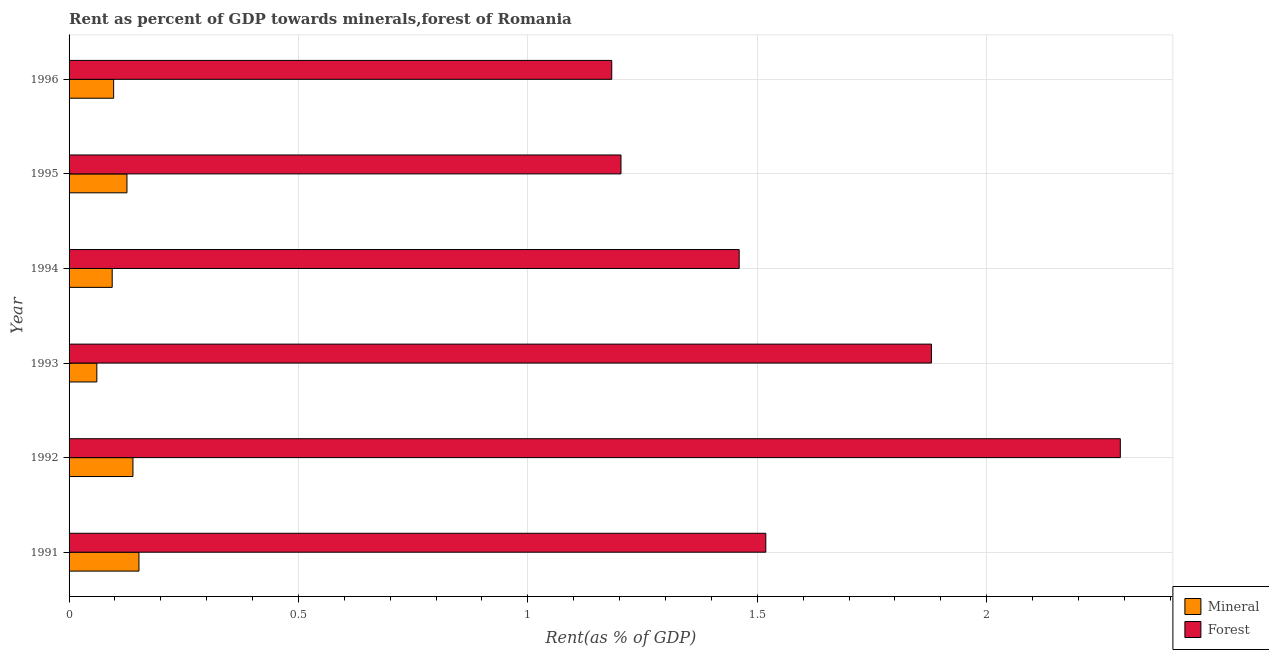How many groups of bars are there?
Make the answer very short. 6. Are the number of bars per tick equal to the number of legend labels?
Keep it short and to the point. Yes. What is the label of the 5th group of bars from the top?
Provide a succinct answer. 1992. What is the forest rent in 1994?
Your answer should be compact. 1.46. Across all years, what is the maximum forest rent?
Offer a terse response. 2.29. Across all years, what is the minimum mineral rent?
Ensure brevity in your answer.  0.06. In which year was the forest rent minimum?
Offer a terse response. 1996. What is the total forest rent in the graph?
Keep it short and to the point. 9.54. What is the difference between the mineral rent in 1993 and that in 1995?
Provide a succinct answer. -0.07. What is the difference between the forest rent in 1992 and the mineral rent in 1993?
Your answer should be compact. 2.23. What is the average mineral rent per year?
Provide a succinct answer. 0.11. In the year 1994, what is the difference between the forest rent and mineral rent?
Ensure brevity in your answer.  1.37. In how many years, is the mineral rent greater than 0.4 %?
Your answer should be compact. 0. What is the ratio of the forest rent in 1993 to that in 1994?
Your answer should be compact. 1.29. Is the forest rent in 1993 less than that in 1996?
Offer a very short reply. No. What is the difference between the highest and the second highest mineral rent?
Your response must be concise. 0.01. What is the difference between the highest and the lowest forest rent?
Ensure brevity in your answer.  1.11. Is the sum of the forest rent in 1991 and 1996 greater than the maximum mineral rent across all years?
Ensure brevity in your answer.  Yes. What does the 2nd bar from the top in 1991 represents?
Your response must be concise. Mineral. What does the 2nd bar from the bottom in 1994 represents?
Your response must be concise. Forest. How many bars are there?
Offer a terse response. 12. Are all the bars in the graph horizontal?
Provide a short and direct response. Yes. What is the difference between two consecutive major ticks on the X-axis?
Provide a succinct answer. 0.5. How many legend labels are there?
Provide a succinct answer. 2. How are the legend labels stacked?
Your answer should be very brief. Vertical. What is the title of the graph?
Make the answer very short. Rent as percent of GDP towards minerals,forest of Romania. What is the label or title of the X-axis?
Give a very brief answer. Rent(as % of GDP). What is the label or title of the Y-axis?
Keep it short and to the point. Year. What is the Rent(as % of GDP) in Mineral in 1991?
Your answer should be compact. 0.15. What is the Rent(as % of GDP) of Forest in 1991?
Keep it short and to the point. 1.52. What is the Rent(as % of GDP) in Mineral in 1992?
Your answer should be very brief. 0.14. What is the Rent(as % of GDP) in Forest in 1992?
Make the answer very short. 2.29. What is the Rent(as % of GDP) of Mineral in 1993?
Make the answer very short. 0.06. What is the Rent(as % of GDP) in Forest in 1993?
Ensure brevity in your answer.  1.88. What is the Rent(as % of GDP) in Mineral in 1994?
Your response must be concise. 0.09. What is the Rent(as % of GDP) of Forest in 1994?
Keep it short and to the point. 1.46. What is the Rent(as % of GDP) of Mineral in 1995?
Provide a short and direct response. 0.13. What is the Rent(as % of GDP) in Forest in 1995?
Ensure brevity in your answer.  1.2. What is the Rent(as % of GDP) in Mineral in 1996?
Provide a short and direct response. 0.1. What is the Rent(as % of GDP) of Forest in 1996?
Your response must be concise. 1.18. Across all years, what is the maximum Rent(as % of GDP) of Mineral?
Provide a short and direct response. 0.15. Across all years, what is the maximum Rent(as % of GDP) of Forest?
Ensure brevity in your answer.  2.29. Across all years, what is the minimum Rent(as % of GDP) of Mineral?
Give a very brief answer. 0.06. Across all years, what is the minimum Rent(as % of GDP) of Forest?
Offer a terse response. 1.18. What is the total Rent(as % of GDP) in Mineral in the graph?
Offer a very short reply. 0.67. What is the total Rent(as % of GDP) of Forest in the graph?
Give a very brief answer. 9.54. What is the difference between the Rent(as % of GDP) in Mineral in 1991 and that in 1992?
Give a very brief answer. 0.01. What is the difference between the Rent(as % of GDP) of Forest in 1991 and that in 1992?
Keep it short and to the point. -0.77. What is the difference between the Rent(as % of GDP) of Mineral in 1991 and that in 1993?
Provide a succinct answer. 0.09. What is the difference between the Rent(as % of GDP) in Forest in 1991 and that in 1993?
Provide a succinct answer. -0.36. What is the difference between the Rent(as % of GDP) of Mineral in 1991 and that in 1994?
Offer a terse response. 0.06. What is the difference between the Rent(as % of GDP) in Forest in 1991 and that in 1994?
Provide a short and direct response. 0.06. What is the difference between the Rent(as % of GDP) in Mineral in 1991 and that in 1995?
Make the answer very short. 0.03. What is the difference between the Rent(as % of GDP) of Forest in 1991 and that in 1995?
Offer a very short reply. 0.32. What is the difference between the Rent(as % of GDP) of Mineral in 1991 and that in 1996?
Offer a terse response. 0.06. What is the difference between the Rent(as % of GDP) of Forest in 1991 and that in 1996?
Provide a succinct answer. 0.34. What is the difference between the Rent(as % of GDP) in Mineral in 1992 and that in 1993?
Ensure brevity in your answer.  0.08. What is the difference between the Rent(as % of GDP) of Forest in 1992 and that in 1993?
Provide a succinct answer. 0.41. What is the difference between the Rent(as % of GDP) of Mineral in 1992 and that in 1994?
Your response must be concise. 0.05. What is the difference between the Rent(as % of GDP) in Forest in 1992 and that in 1994?
Your answer should be compact. 0.83. What is the difference between the Rent(as % of GDP) of Mineral in 1992 and that in 1995?
Provide a short and direct response. 0.01. What is the difference between the Rent(as % of GDP) of Forest in 1992 and that in 1995?
Keep it short and to the point. 1.09. What is the difference between the Rent(as % of GDP) in Mineral in 1992 and that in 1996?
Keep it short and to the point. 0.04. What is the difference between the Rent(as % of GDP) in Forest in 1992 and that in 1996?
Give a very brief answer. 1.11. What is the difference between the Rent(as % of GDP) in Mineral in 1993 and that in 1994?
Your response must be concise. -0.03. What is the difference between the Rent(as % of GDP) of Forest in 1993 and that in 1994?
Your answer should be compact. 0.42. What is the difference between the Rent(as % of GDP) in Mineral in 1993 and that in 1995?
Make the answer very short. -0.07. What is the difference between the Rent(as % of GDP) of Forest in 1993 and that in 1995?
Give a very brief answer. 0.68. What is the difference between the Rent(as % of GDP) in Mineral in 1993 and that in 1996?
Your answer should be compact. -0.04. What is the difference between the Rent(as % of GDP) of Forest in 1993 and that in 1996?
Offer a terse response. 0.7. What is the difference between the Rent(as % of GDP) of Mineral in 1994 and that in 1995?
Provide a short and direct response. -0.03. What is the difference between the Rent(as % of GDP) of Forest in 1994 and that in 1995?
Provide a short and direct response. 0.26. What is the difference between the Rent(as % of GDP) in Mineral in 1994 and that in 1996?
Give a very brief answer. -0. What is the difference between the Rent(as % of GDP) in Forest in 1994 and that in 1996?
Make the answer very short. 0.28. What is the difference between the Rent(as % of GDP) of Mineral in 1995 and that in 1996?
Ensure brevity in your answer.  0.03. What is the difference between the Rent(as % of GDP) in Forest in 1995 and that in 1996?
Your answer should be very brief. 0.02. What is the difference between the Rent(as % of GDP) in Mineral in 1991 and the Rent(as % of GDP) in Forest in 1992?
Offer a terse response. -2.14. What is the difference between the Rent(as % of GDP) in Mineral in 1991 and the Rent(as % of GDP) in Forest in 1993?
Provide a succinct answer. -1.73. What is the difference between the Rent(as % of GDP) of Mineral in 1991 and the Rent(as % of GDP) of Forest in 1994?
Keep it short and to the point. -1.31. What is the difference between the Rent(as % of GDP) of Mineral in 1991 and the Rent(as % of GDP) of Forest in 1995?
Make the answer very short. -1.05. What is the difference between the Rent(as % of GDP) of Mineral in 1991 and the Rent(as % of GDP) of Forest in 1996?
Provide a short and direct response. -1.03. What is the difference between the Rent(as % of GDP) of Mineral in 1992 and the Rent(as % of GDP) of Forest in 1993?
Keep it short and to the point. -1.74. What is the difference between the Rent(as % of GDP) of Mineral in 1992 and the Rent(as % of GDP) of Forest in 1994?
Your response must be concise. -1.32. What is the difference between the Rent(as % of GDP) of Mineral in 1992 and the Rent(as % of GDP) of Forest in 1995?
Your response must be concise. -1.06. What is the difference between the Rent(as % of GDP) of Mineral in 1992 and the Rent(as % of GDP) of Forest in 1996?
Provide a succinct answer. -1.04. What is the difference between the Rent(as % of GDP) of Mineral in 1993 and the Rent(as % of GDP) of Forest in 1994?
Your answer should be very brief. -1.4. What is the difference between the Rent(as % of GDP) in Mineral in 1993 and the Rent(as % of GDP) in Forest in 1995?
Make the answer very short. -1.14. What is the difference between the Rent(as % of GDP) in Mineral in 1993 and the Rent(as % of GDP) in Forest in 1996?
Make the answer very short. -1.12. What is the difference between the Rent(as % of GDP) in Mineral in 1994 and the Rent(as % of GDP) in Forest in 1995?
Make the answer very short. -1.11. What is the difference between the Rent(as % of GDP) in Mineral in 1994 and the Rent(as % of GDP) in Forest in 1996?
Your response must be concise. -1.09. What is the difference between the Rent(as % of GDP) in Mineral in 1995 and the Rent(as % of GDP) in Forest in 1996?
Provide a succinct answer. -1.06. What is the average Rent(as % of GDP) of Mineral per year?
Offer a terse response. 0.11. What is the average Rent(as % of GDP) in Forest per year?
Your response must be concise. 1.59. In the year 1991, what is the difference between the Rent(as % of GDP) of Mineral and Rent(as % of GDP) of Forest?
Provide a short and direct response. -1.37. In the year 1992, what is the difference between the Rent(as % of GDP) of Mineral and Rent(as % of GDP) of Forest?
Your response must be concise. -2.15. In the year 1993, what is the difference between the Rent(as % of GDP) of Mineral and Rent(as % of GDP) of Forest?
Provide a succinct answer. -1.82. In the year 1994, what is the difference between the Rent(as % of GDP) of Mineral and Rent(as % of GDP) of Forest?
Ensure brevity in your answer.  -1.37. In the year 1995, what is the difference between the Rent(as % of GDP) in Mineral and Rent(as % of GDP) in Forest?
Your answer should be very brief. -1.08. In the year 1996, what is the difference between the Rent(as % of GDP) of Mineral and Rent(as % of GDP) of Forest?
Your answer should be compact. -1.09. What is the ratio of the Rent(as % of GDP) of Mineral in 1991 to that in 1992?
Offer a very short reply. 1.09. What is the ratio of the Rent(as % of GDP) of Forest in 1991 to that in 1992?
Your answer should be compact. 0.66. What is the ratio of the Rent(as % of GDP) in Mineral in 1991 to that in 1993?
Keep it short and to the point. 2.52. What is the ratio of the Rent(as % of GDP) of Forest in 1991 to that in 1993?
Your answer should be compact. 0.81. What is the ratio of the Rent(as % of GDP) in Mineral in 1991 to that in 1994?
Your answer should be compact. 1.62. What is the ratio of the Rent(as % of GDP) in Forest in 1991 to that in 1994?
Offer a very short reply. 1.04. What is the ratio of the Rent(as % of GDP) of Mineral in 1991 to that in 1995?
Provide a short and direct response. 1.21. What is the ratio of the Rent(as % of GDP) of Forest in 1991 to that in 1995?
Offer a terse response. 1.26. What is the ratio of the Rent(as % of GDP) in Mineral in 1991 to that in 1996?
Your answer should be very brief. 1.57. What is the ratio of the Rent(as % of GDP) of Forest in 1991 to that in 1996?
Offer a very short reply. 1.28. What is the ratio of the Rent(as % of GDP) in Mineral in 1992 to that in 1993?
Your answer should be very brief. 2.3. What is the ratio of the Rent(as % of GDP) of Forest in 1992 to that in 1993?
Your answer should be compact. 1.22. What is the ratio of the Rent(as % of GDP) of Mineral in 1992 to that in 1994?
Your response must be concise. 1.48. What is the ratio of the Rent(as % of GDP) in Forest in 1992 to that in 1994?
Provide a succinct answer. 1.57. What is the ratio of the Rent(as % of GDP) in Mineral in 1992 to that in 1995?
Your answer should be very brief. 1.1. What is the ratio of the Rent(as % of GDP) of Forest in 1992 to that in 1995?
Offer a very short reply. 1.9. What is the ratio of the Rent(as % of GDP) of Mineral in 1992 to that in 1996?
Make the answer very short. 1.43. What is the ratio of the Rent(as % of GDP) in Forest in 1992 to that in 1996?
Your answer should be very brief. 1.94. What is the ratio of the Rent(as % of GDP) in Mineral in 1993 to that in 1994?
Offer a very short reply. 0.64. What is the ratio of the Rent(as % of GDP) of Forest in 1993 to that in 1994?
Provide a short and direct response. 1.29. What is the ratio of the Rent(as % of GDP) in Mineral in 1993 to that in 1995?
Your response must be concise. 0.48. What is the ratio of the Rent(as % of GDP) in Forest in 1993 to that in 1995?
Your answer should be very brief. 1.56. What is the ratio of the Rent(as % of GDP) in Mineral in 1993 to that in 1996?
Your answer should be very brief. 0.62. What is the ratio of the Rent(as % of GDP) of Forest in 1993 to that in 1996?
Offer a very short reply. 1.59. What is the ratio of the Rent(as % of GDP) of Mineral in 1994 to that in 1995?
Your response must be concise. 0.75. What is the ratio of the Rent(as % of GDP) of Forest in 1994 to that in 1995?
Offer a terse response. 1.21. What is the ratio of the Rent(as % of GDP) in Forest in 1994 to that in 1996?
Your response must be concise. 1.23. What is the ratio of the Rent(as % of GDP) of Mineral in 1995 to that in 1996?
Your answer should be compact. 1.3. What is the ratio of the Rent(as % of GDP) in Forest in 1995 to that in 1996?
Offer a terse response. 1.02. What is the difference between the highest and the second highest Rent(as % of GDP) of Mineral?
Provide a succinct answer. 0.01. What is the difference between the highest and the second highest Rent(as % of GDP) in Forest?
Offer a terse response. 0.41. What is the difference between the highest and the lowest Rent(as % of GDP) of Mineral?
Ensure brevity in your answer.  0.09. What is the difference between the highest and the lowest Rent(as % of GDP) in Forest?
Your answer should be compact. 1.11. 